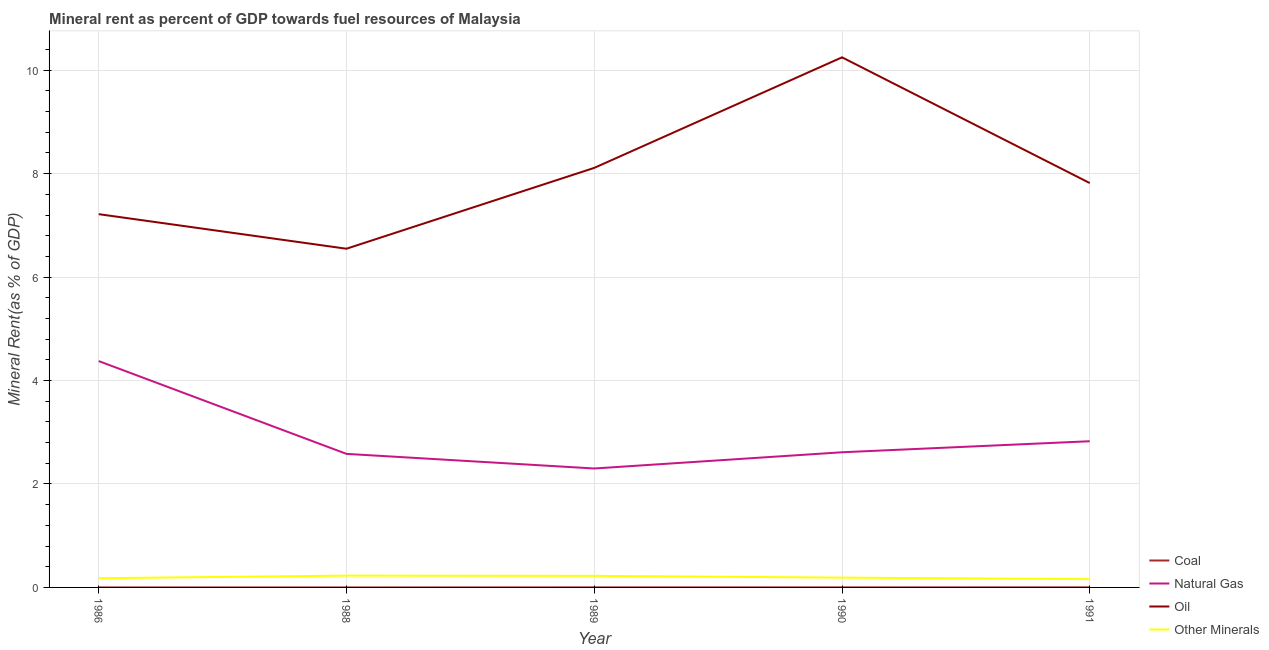How many different coloured lines are there?
Your answer should be very brief. 4. What is the coal rent in 1986?
Provide a short and direct response. 0. Across all years, what is the maximum oil rent?
Your answer should be compact. 10.25. Across all years, what is the minimum oil rent?
Provide a short and direct response. 6.55. In which year was the natural gas rent maximum?
Ensure brevity in your answer.  1986. What is the total  rent of other minerals in the graph?
Give a very brief answer. 0.98. What is the difference between the natural gas rent in 1990 and that in 1991?
Provide a short and direct response. -0.21. What is the difference between the oil rent in 1991 and the  rent of other minerals in 1990?
Ensure brevity in your answer.  7.63. What is the average coal rent per year?
Your response must be concise. 0. In the year 1991, what is the difference between the oil rent and coal rent?
Offer a terse response. 7.82. What is the ratio of the natural gas rent in 1989 to that in 1991?
Keep it short and to the point. 0.81. What is the difference between the highest and the second highest natural gas rent?
Offer a very short reply. 1.55. What is the difference between the highest and the lowest oil rent?
Keep it short and to the point. 3.7. Is it the case that in every year, the sum of the  rent of other minerals and coal rent is greater than the sum of natural gas rent and oil rent?
Your response must be concise. No. Does the natural gas rent monotonically increase over the years?
Keep it short and to the point. No. Is the  rent of other minerals strictly greater than the natural gas rent over the years?
Keep it short and to the point. No. How many years are there in the graph?
Make the answer very short. 5. Are the values on the major ticks of Y-axis written in scientific E-notation?
Make the answer very short. No. Does the graph contain any zero values?
Offer a terse response. No. Does the graph contain grids?
Your response must be concise. Yes. How are the legend labels stacked?
Your response must be concise. Vertical. What is the title of the graph?
Your answer should be very brief. Mineral rent as percent of GDP towards fuel resources of Malaysia. What is the label or title of the X-axis?
Your answer should be very brief. Year. What is the label or title of the Y-axis?
Offer a very short reply. Mineral Rent(as % of GDP). What is the Mineral Rent(as % of GDP) in Coal in 1986?
Keep it short and to the point. 0. What is the Mineral Rent(as % of GDP) of Natural Gas in 1986?
Your answer should be very brief. 4.38. What is the Mineral Rent(as % of GDP) in Oil in 1986?
Make the answer very short. 7.22. What is the Mineral Rent(as % of GDP) in Other Minerals in 1986?
Give a very brief answer. 0.18. What is the Mineral Rent(as % of GDP) of Coal in 1988?
Provide a succinct answer. 2.78843758347685e-6. What is the Mineral Rent(as % of GDP) in Natural Gas in 1988?
Make the answer very short. 2.58. What is the Mineral Rent(as % of GDP) in Oil in 1988?
Give a very brief answer. 6.55. What is the Mineral Rent(as % of GDP) of Other Minerals in 1988?
Your answer should be compact. 0.23. What is the Mineral Rent(as % of GDP) of Coal in 1989?
Your answer should be compact. 0. What is the Mineral Rent(as % of GDP) of Natural Gas in 1989?
Offer a terse response. 2.3. What is the Mineral Rent(as % of GDP) of Oil in 1989?
Offer a very short reply. 8.11. What is the Mineral Rent(as % of GDP) of Other Minerals in 1989?
Provide a succinct answer. 0.22. What is the Mineral Rent(as % of GDP) of Coal in 1990?
Ensure brevity in your answer.  0. What is the Mineral Rent(as % of GDP) in Natural Gas in 1990?
Ensure brevity in your answer.  2.61. What is the Mineral Rent(as % of GDP) of Oil in 1990?
Give a very brief answer. 10.25. What is the Mineral Rent(as % of GDP) of Other Minerals in 1990?
Your answer should be compact. 0.19. What is the Mineral Rent(as % of GDP) in Coal in 1991?
Give a very brief answer. 0. What is the Mineral Rent(as % of GDP) of Natural Gas in 1991?
Make the answer very short. 2.83. What is the Mineral Rent(as % of GDP) in Oil in 1991?
Provide a succinct answer. 7.82. What is the Mineral Rent(as % of GDP) of Other Minerals in 1991?
Your response must be concise. 0.16. Across all years, what is the maximum Mineral Rent(as % of GDP) of Coal?
Make the answer very short. 0. Across all years, what is the maximum Mineral Rent(as % of GDP) in Natural Gas?
Make the answer very short. 4.38. Across all years, what is the maximum Mineral Rent(as % of GDP) of Oil?
Your answer should be compact. 10.25. Across all years, what is the maximum Mineral Rent(as % of GDP) of Other Minerals?
Your answer should be very brief. 0.23. Across all years, what is the minimum Mineral Rent(as % of GDP) in Coal?
Offer a terse response. 2.78843758347685e-6. Across all years, what is the minimum Mineral Rent(as % of GDP) of Natural Gas?
Offer a very short reply. 2.3. Across all years, what is the minimum Mineral Rent(as % of GDP) in Oil?
Offer a terse response. 6.55. Across all years, what is the minimum Mineral Rent(as % of GDP) of Other Minerals?
Your answer should be compact. 0.16. What is the total Mineral Rent(as % of GDP) in Coal in the graph?
Provide a succinct answer. 0. What is the total Mineral Rent(as % of GDP) in Natural Gas in the graph?
Ensure brevity in your answer.  14.7. What is the total Mineral Rent(as % of GDP) in Oil in the graph?
Your answer should be compact. 39.94. What is the total Mineral Rent(as % of GDP) in Other Minerals in the graph?
Your response must be concise. 0.98. What is the difference between the Mineral Rent(as % of GDP) in Natural Gas in 1986 and that in 1988?
Give a very brief answer. 1.79. What is the difference between the Mineral Rent(as % of GDP) in Oil in 1986 and that in 1988?
Provide a succinct answer. 0.67. What is the difference between the Mineral Rent(as % of GDP) of Other Minerals in 1986 and that in 1988?
Your answer should be very brief. -0.05. What is the difference between the Mineral Rent(as % of GDP) in Coal in 1986 and that in 1989?
Your answer should be very brief. -0. What is the difference between the Mineral Rent(as % of GDP) of Natural Gas in 1986 and that in 1989?
Your answer should be very brief. 2.08. What is the difference between the Mineral Rent(as % of GDP) of Oil in 1986 and that in 1989?
Make the answer very short. -0.89. What is the difference between the Mineral Rent(as % of GDP) in Other Minerals in 1986 and that in 1989?
Provide a short and direct response. -0.05. What is the difference between the Mineral Rent(as % of GDP) of Coal in 1986 and that in 1990?
Offer a terse response. -0. What is the difference between the Mineral Rent(as % of GDP) in Natural Gas in 1986 and that in 1990?
Offer a terse response. 1.76. What is the difference between the Mineral Rent(as % of GDP) in Oil in 1986 and that in 1990?
Offer a very short reply. -3.03. What is the difference between the Mineral Rent(as % of GDP) of Other Minerals in 1986 and that in 1990?
Provide a succinct answer. -0.01. What is the difference between the Mineral Rent(as % of GDP) in Coal in 1986 and that in 1991?
Keep it short and to the point. -0. What is the difference between the Mineral Rent(as % of GDP) of Natural Gas in 1986 and that in 1991?
Ensure brevity in your answer.  1.55. What is the difference between the Mineral Rent(as % of GDP) of Oil in 1986 and that in 1991?
Ensure brevity in your answer.  -0.6. What is the difference between the Mineral Rent(as % of GDP) of Other Minerals in 1986 and that in 1991?
Provide a succinct answer. 0.02. What is the difference between the Mineral Rent(as % of GDP) in Coal in 1988 and that in 1989?
Give a very brief answer. -0. What is the difference between the Mineral Rent(as % of GDP) of Natural Gas in 1988 and that in 1989?
Offer a terse response. 0.28. What is the difference between the Mineral Rent(as % of GDP) in Oil in 1988 and that in 1989?
Ensure brevity in your answer.  -1.56. What is the difference between the Mineral Rent(as % of GDP) in Other Minerals in 1988 and that in 1989?
Your response must be concise. 0. What is the difference between the Mineral Rent(as % of GDP) in Coal in 1988 and that in 1990?
Your answer should be very brief. -0. What is the difference between the Mineral Rent(as % of GDP) of Natural Gas in 1988 and that in 1990?
Offer a terse response. -0.03. What is the difference between the Mineral Rent(as % of GDP) in Oil in 1988 and that in 1990?
Keep it short and to the point. -3.7. What is the difference between the Mineral Rent(as % of GDP) of Other Minerals in 1988 and that in 1990?
Provide a succinct answer. 0.04. What is the difference between the Mineral Rent(as % of GDP) of Coal in 1988 and that in 1991?
Your answer should be very brief. -0. What is the difference between the Mineral Rent(as % of GDP) of Natural Gas in 1988 and that in 1991?
Keep it short and to the point. -0.24. What is the difference between the Mineral Rent(as % of GDP) in Oil in 1988 and that in 1991?
Provide a succinct answer. -1.27. What is the difference between the Mineral Rent(as % of GDP) in Other Minerals in 1988 and that in 1991?
Provide a short and direct response. 0.07. What is the difference between the Mineral Rent(as % of GDP) in Coal in 1989 and that in 1990?
Offer a very short reply. -0. What is the difference between the Mineral Rent(as % of GDP) of Natural Gas in 1989 and that in 1990?
Offer a very short reply. -0.31. What is the difference between the Mineral Rent(as % of GDP) of Oil in 1989 and that in 1990?
Your response must be concise. -2.14. What is the difference between the Mineral Rent(as % of GDP) of Other Minerals in 1989 and that in 1990?
Give a very brief answer. 0.03. What is the difference between the Mineral Rent(as % of GDP) in Coal in 1989 and that in 1991?
Provide a succinct answer. -0. What is the difference between the Mineral Rent(as % of GDP) of Natural Gas in 1989 and that in 1991?
Your answer should be very brief. -0.53. What is the difference between the Mineral Rent(as % of GDP) of Oil in 1989 and that in 1991?
Make the answer very short. 0.29. What is the difference between the Mineral Rent(as % of GDP) in Other Minerals in 1989 and that in 1991?
Your answer should be very brief. 0.06. What is the difference between the Mineral Rent(as % of GDP) of Coal in 1990 and that in 1991?
Your response must be concise. -0. What is the difference between the Mineral Rent(as % of GDP) in Natural Gas in 1990 and that in 1991?
Provide a succinct answer. -0.21. What is the difference between the Mineral Rent(as % of GDP) of Oil in 1990 and that in 1991?
Make the answer very short. 2.43. What is the difference between the Mineral Rent(as % of GDP) in Other Minerals in 1990 and that in 1991?
Keep it short and to the point. 0.03. What is the difference between the Mineral Rent(as % of GDP) in Coal in 1986 and the Mineral Rent(as % of GDP) in Natural Gas in 1988?
Ensure brevity in your answer.  -2.58. What is the difference between the Mineral Rent(as % of GDP) of Coal in 1986 and the Mineral Rent(as % of GDP) of Oil in 1988?
Offer a very short reply. -6.55. What is the difference between the Mineral Rent(as % of GDP) in Coal in 1986 and the Mineral Rent(as % of GDP) in Other Minerals in 1988?
Offer a very short reply. -0.23. What is the difference between the Mineral Rent(as % of GDP) of Natural Gas in 1986 and the Mineral Rent(as % of GDP) of Oil in 1988?
Give a very brief answer. -2.17. What is the difference between the Mineral Rent(as % of GDP) in Natural Gas in 1986 and the Mineral Rent(as % of GDP) in Other Minerals in 1988?
Keep it short and to the point. 4.15. What is the difference between the Mineral Rent(as % of GDP) of Oil in 1986 and the Mineral Rent(as % of GDP) of Other Minerals in 1988?
Your answer should be compact. 6.99. What is the difference between the Mineral Rent(as % of GDP) of Coal in 1986 and the Mineral Rent(as % of GDP) of Natural Gas in 1989?
Offer a very short reply. -2.3. What is the difference between the Mineral Rent(as % of GDP) in Coal in 1986 and the Mineral Rent(as % of GDP) in Oil in 1989?
Offer a terse response. -8.11. What is the difference between the Mineral Rent(as % of GDP) of Coal in 1986 and the Mineral Rent(as % of GDP) of Other Minerals in 1989?
Provide a short and direct response. -0.22. What is the difference between the Mineral Rent(as % of GDP) in Natural Gas in 1986 and the Mineral Rent(as % of GDP) in Oil in 1989?
Offer a very short reply. -3.73. What is the difference between the Mineral Rent(as % of GDP) in Natural Gas in 1986 and the Mineral Rent(as % of GDP) in Other Minerals in 1989?
Your response must be concise. 4.15. What is the difference between the Mineral Rent(as % of GDP) in Oil in 1986 and the Mineral Rent(as % of GDP) in Other Minerals in 1989?
Your response must be concise. 6.99. What is the difference between the Mineral Rent(as % of GDP) in Coal in 1986 and the Mineral Rent(as % of GDP) in Natural Gas in 1990?
Offer a terse response. -2.61. What is the difference between the Mineral Rent(as % of GDP) in Coal in 1986 and the Mineral Rent(as % of GDP) in Oil in 1990?
Offer a terse response. -10.25. What is the difference between the Mineral Rent(as % of GDP) of Coal in 1986 and the Mineral Rent(as % of GDP) of Other Minerals in 1990?
Your answer should be compact. -0.19. What is the difference between the Mineral Rent(as % of GDP) of Natural Gas in 1986 and the Mineral Rent(as % of GDP) of Oil in 1990?
Keep it short and to the point. -5.87. What is the difference between the Mineral Rent(as % of GDP) of Natural Gas in 1986 and the Mineral Rent(as % of GDP) of Other Minerals in 1990?
Keep it short and to the point. 4.19. What is the difference between the Mineral Rent(as % of GDP) of Oil in 1986 and the Mineral Rent(as % of GDP) of Other Minerals in 1990?
Provide a short and direct response. 7.03. What is the difference between the Mineral Rent(as % of GDP) in Coal in 1986 and the Mineral Rent(as % of GDP) in Natural Gas in 1991?
Ensure brevity in your answer.  -2.83. What is the difference between the Mineral Rent(as % of GDP) of Coal in 1986 and the Mineral Rent(as % of GDP) of Oil in 1991?
Your response must be concise. -7.82. What is the difference between the Mineral Rent(as % of GDP) in Coal in 1986 and the Mineral Rent(as % of GDP) in Other Minerals in 1991?
Offer a terse response. -0.16. What is the difference between the Mineral Rent(as % of GDP) in Natural Gas in 1986 and the Mineral Rent(as % of GDP) in Oil in 1991?
Provide a short and direct response. -3.44. What is the difference between the Mineral Rent(as % of GDP) in Natural Gas in 1986 and the Mineral Rent(as % of GDP) in Other Minerals in 1991?
Make the answer very short. 4.22. What is the difference between the Mineral Rent(as % of GDP) in Oil in 1986 and the Mineral Rent(as % of GDP) in Other Minerals in 1991?
Provide a short and direct response. 7.06. What is the difference between the Mineral Rent(as % of GDP) of Coal in 1988 and the Mineral Rent(as % of GDP) of Natural Gas in 1989?
Provide a short and direct response. -2.3. What is the difference between the Mineral Rent(as % of GDP) of Coal in 1988 and the Mineral Rent(as % of GDP) of Oil in 1989?
Ensure brevity in your answer.  -8.11. What is the difference between the Mineral Rent(as % of GDP) in Coal in 1988 and the Mineral Rent(as % of GDP) in Other Minerals in 1989?
Your answer should be very brief. -0.22. What is the difference between the Mineral Rent(as % of GDP) in Natural Gas in 1988 and the Mineral Rent(as % of GDP) in Oil in 1989?
Offer a very short reply. -5.53. What is the difference between the Mineral Rent(as % of GDP) of Natural Gas in 1988 and the Mineral Rent(as % of GDP) of Other Minerals in 1989?
Your answer should be very brief. 2.36. What is the difference between the Mineral Rent(as % of GDP) in Oil in 1988 and the Mineral Rent(as % of GDP) in Other Minerals in 1989?
Your answer should be compact. 6.32. What is the difference between the Mineral Rent(as % of GDP) of Coal in 1988 and the Mineral Rent(as % of GDP) of Natural Gas in 1990?
Make the answer very short. -2.61. What is the difference between the Mineral Rent(as % of GDP) of Coal in 1988 and the Mineral Rent(as % of GDP) of Oil in 1990?
Offer a very short reply. -10.25. What is the difference between the Mineral Rent(as % of GDP) of Coal in 1988 and the Mineral Rent(as % of GDP) of Other Minerals in 1990?
Ensure brevity in your answer.  -0.19. What is the difference between the Mineral Rent(as % of GDP) in Natural Gas in 1988 and the Mineral Rent(as % of GDP) in Oil in 1990?
Provide a short and direct response. -7.67. What is the difference between the Mineral Rent(as % of GDP) in Natural Gas in 1988 and the Mineral Rent(as % of GDP) in Other Minerals in 1990?
Your answer should be compact. 2.39. What is the difference between the Mineral Rent(as % of GDP) in Oil in 1988 and the Mineral Rent(as % of GDP) in Other Minerals in 1990?
Make the answer very short. 6.36. What is the difference between the Mineral Rent(as % of GDP) of Coal in 1988 and the Mineral Rent(as % of GDP) of Natural Gas in 1991?
Offer a terse response. -2.83. What is the difference between the Mineral Rent(as % of GDP) of Coal in 1988 and the Mineral Rent(as % of GDP) of Oil in 1991?
Offer a very short reply. -7.82. What is the difference between the Mineral Rent(as % of GDP) of Coal in 1988 and the Mineral Rent(as % of GDP) of Other Minerals in 1991?
Your answer should be compact. -0.16. What is the difference between the Mineral Rent(as % of GDP) of Natural Gas in 1988 and the Mineral Rent(as % of GDP) of Oil in 1991?
Offer a terse response. -5.24. What is the difference between the Mineral Rent(as % of GDP) of Natural Gas in 1988 and the Mineral Rent(as % of GDP) of Other Minerals in 1991?
Your response must be concise. 2.42. What is the difference between the Mineral Rent(as % of GDP) of Oil in 1988 and the Mineral Rent(as % of GDP) of Other Minerals in 1991?
Make the answer very short. 6.39. What is the difference between the Mineral Rent(as % of GDP) in Coal in 1989 and the Mineral Rent(as % of GDP) in Natural Gas in 1990?
Your response must be concise. -2.61. What is the difference between the Mineral Rent(as % of GDP) in Coal in 1989 and the Mineral Rent(as % of GDP) in Oil in 1990?
Provide a succinct answer. -10.25. What is the difference between the Mineral Rent(as % of GDP) of Coal in 1989 and the Mineral Rent(as % of GDP) of Other Minerals in 1990?
Provide a short and direct response. -0.19. What is the difference between the Mineral Rent(as % of GDP) in Natural Gas in 1989 and the Mineral Rent(as % of GDP) in Oil in 1990?
Offer a terse response. -7.95. What is the difference between the Mineral Rent(as % of GDP) of Natural Gas in 1989 and the Mineral Rent(as % of GDP) of Other Minerals in 1990?
Provide a short and direct response. 2.11. What is the difference between the Mineral Rent(as % of GDP) in Oil in 1989 and the Mineral Rent(as % of GDP) in Other Minerals in 1990?
Your answer should be compact. 7.92. What is the difference between the Mineral Rent(as % of GDP) in Coal in 1989 and the Mineral Rent(as % of GDP) in Natural Gas in 1991?
Offer a very short reply. -2.83. What is the difference between the Mineral Rent(as % of GDP) in Coal in 1989 and the Mineral Rent(as % of GDP) in Oil in 1991?
Your response must be concise. -7.82. What is the difference between the Mineral Rent(as % of GDP) in Coal in 1989 and the Mineral Rent(as % of GDP) in Other Minerals in 1991?
Give a very brief answer. -0.16. What is the difference between the Mineral Rent(as % of GDP) of Natural Gas in 1989 and the Mineral Rent(as % of GDP) of Oil in 1991?
Offer a very short reply. -5.52. What is the difference between the Mineral Rent(as % of GDP) in Natural Gas in 1989 and the Mineral Rent(as % of GDP) in Other Minerals in 1991?
Give a very brief answer. 2.14. What is the difference between the Mineral Rent(as % of GDP) in Oil in 1989 and the Mineral Rent(as % of GDP) in Other Minerals in 1991?
Keep it short and to the point. 7.95. What is the difference between the Mineral Rent(as % of GDP) in Coal in 1990 and the Mineral Rent(as % of GDP) in Natural Gas in 1991?
Offer a terse response. -2.83. What is the difference between the Mineral Rent(as % of GDP) in Coal in 1990 and the Mineral Rent(as % of GDP) in Oil in 1991?
Your answer should be very brief. -7.82. What is the difference between the Mineral Rent(as % of GDP) in Coal in 1990 and the Mineral Rent(as % of GDP) in Other Minerals in 1991?
Keep it short and to the point. -0.16. What is the difference between the Mineral Rent(as % of GDP) in Natural Gas in 1990 and the Mineral Rent(as % of GDP) in Oil in 1991?
Ensure brevity in your answer.  -5.2. What is the difference between the Mineral Rent(as % of GDP) in Natural Gas in 1990 and the Mineral Rent(as % of GDP) in Other Minerals in 1991?
Provide a succinct answer. 2.45. What is the difference between the Mineral Rent(as % of GDP) in Oil in 1990 and the Mineral Rent(as % of GDP) in Other Minerals in 1991?
Your answer should be compact. 10.09. What is the average Mineral Rent(as % of GDP) of Coal per year?
Ensure brevity in your answer.  0. What is the average Mineral Rent(as % of GDP) in Natural Gas per year?
Provide a short and direct response. 2.94. What is the average Mineral Rent(as % of GDP) of Oil per year?
Provide a short and direct response. 7.99. What is the average Mineral Rent(as % of GDP) in Other Minerals per year?
Make the answer very short. 0.2. In the year 1986, what is the difference between the Mineral Rent(as % of GDP) of Coal and Mineral Rent(as % of GDP) of Natural Gas?
Give a very brief answer. -4.38. In the year 1986, what is the difference between the Mineral Rent(as % of GDP) of Coal and Mineral Rent(as % of GDP) of Oil?
Offer a very short reply. -7.22. In the year 1986, what is the difference between the Mineral Rent(as % of GDP) in Coal and Mineral Rent(as % of GDP) in Other Minerals?
Offer a very short reply. -0.18. In the year 1986, what is the difference between the Mineral Rent(as % of GDP) in Natural Gas and Mineral Rent(as % of GDP) in Oil?
Give a very brief answer. -2.84. In the year 1986, what is the difference between the Mineral Rent(as % of GDP) in Natural Gas and Mineral Rent(as % of GDP) in Other Minerals?
Offer a terse response. 4.2. In the year 1986, what is the difference between the Mineral Rent(as % of GDP) of Oil and Mineral Rent(as % of GDP) of Other Minerals?
Offer a very short reply. 7.04. In the year 1988, what is the difference between the Mineral Rent(as % of GDP) in Coal and Mineral Rent(as % of GDP) in Natural Gas?
Provide a succinct answer. -2.58. In the year 1988, what is the difference between the Mineral Rent(as % of GDP) in Coal and Mineral Rent(as % of GDP) in Oil?
Make the answer very short. -6.55. In the year 1988, what is the difference between the Mineral Rent(as % of GDP) in Coal and Mineral Rent(as % of GDP) in Other Minerals?
Provide a short and direct response. -0.23. In the year 1988, what is the difference between the Mineral Rent(as % of GDP) in Natural Gas and Mineral Rent(as % of GDP) in Oil?
Your answer should be very brief. -3.97. In the year 1988, what is the difference between the Mineral Rent(as % of GDP) of Natural Gas and Mineral Rent(as % of GDP) of Other Minerals?
Give a very brief answer. 2.35. In the year 1988, what is the difference between the Mineral Rent(as % of GDP) of Oil and Mineral Rent(as % of GDP) of Other Minerals?
Provide a succinct answer. 6.32. In the year 1989, what is the difference between the Mineral Rent(as % of GDP) of Coal and Mineral Rent(as % of GDP) of Natural Gas?
Provide a short and direct response. -2.3. In the year 1989, what is the difference between the Mineral Rent(as % of GDP) in Coal and Mineral Rent(as % of GDP) in Oil?
Your answer should be compact. -8.11. In the year 1989, what is the difference between the Mineral Rent(as % of GDP) in Coal and Mineral Rent(as % of GDP) in Other Minerals?
Provide a short and direct response. -0.22. In the year 1989, what is the difference between the Mineral Rent(as % of GDP) in Natural Gas and Mineral Rent(as % of GDP) in Oil?
Provide a short and direct response. -5.81. In the year 1989, what is the difference between the Mineral Rent(as % of GDP) in Natural Gas and Mineral Rent(as % of GDP) in Other Minerals?
Ensure brevity in your answer.  2.08. In the year 1989, what is the difference between the Mineral Rent(as % of GDP) of Oil and Mineral Rent(as % of GDP) of Other Minerals?
Keep it short and to the point. 7.89. In the year 1990, what is the difference between the Mineral Rent(as % of GDP) in Coal and Mineral Rent(as % of GDP) in Natural Gas?
Ensure brevity in your answer.  -2.61. In the year 1990, what is the difference between the Mineral Rent(as % of GDP) in Coal and Mineral Rent(as % of GDP) in Oil?
Ensure brevity in your answer.  -10.25. In the year 1990, what is the difference between the Mineral Rent(as % of GDP) of Coal and Mineral Rent(as % of GDP) of Other Minerals?
Make the answer very short. -0.19. In the year 1990, what is the difference between the Mineral Rent(as % of GDP) of Natural Gas and Mineral Rent(as % of GDP) of Oil?
Keep it short and to the point. -7.64. In the year 1990, what is the difference between the Mineral Rent(as % of GDP) in Natural Gas and Mineral Rent(as % of GDP) in Other Minerals?
Ensure brevity in your answer.  2.42. In the year 1990, what is the difference between the Mineral Rent(as % of GDP) of Oil and Mineral Rent(as % of GDP) of Other Minerals?
Your response must be concise. 10.06. In the year 1991, what is the difference between the Mineral Rent(as % of GDP) in Coal and Mineral Rent(as % of GDP) in Natural Gas?
Give a very brief answer. -2.83. In the year 1991, what is the difference between the Mineral Rent(as % of GDP) of Coal and Mineral Rent(as % of GDP) of Oil?
Ensure brevity in your answer.  -7.82. In the year 1991, what is the difference between the Mineral Rent(as % of GDP) in Coal and Mineral Rent(as % of GDP) in Other Minerals?
Offer a terse response. -0.16. In the year 1991, what is the difference between the Mineral Rent(as % of GDP) in Natural Gas and Mineral Rent(as % of GDP) in Oil?
Your response must be concise. -4.99. In the year 1991, what is the difference between the Mineral Rent(as % of GDP) in Natural Gas and Mineral Rent(as % of GDP) in Other Minerals?
Offer a terse response. 2.67. In the year 1991, what is the difference between the Mineral Rent(as % of GDP) of Oil and Mineral Rent(as % of GDP) of Other Minerals?
Provide a succinct answer. 7.66. What is the ratio of the Mineral Rent(as % of GDP) of Coal in 1986 to that in 1988?
Offer a terse response. 95.67. What is the ratio of the Mineral Rent(as % of GDP) in Natural Gas in 1986 to that in 1988?
Your response must be concise. 1.69. What is the ratio of the Mineral Rent(as % of GDP) of Oil in 1986 to that in 1988?
Offer a terse response. 1.1. What is the ratio of the Mineral Rent(as % of GDP) in Other Minerals in 1986 to that in 1988?
Give a very brief answer. 0.78. What is the ratio of the Mineral Rent(as % of GDP) in Coal in 1986 to that in 1989?
Provide a short and direct response. 0.31. What is the ratio of the Mineral Rent(as % of GDP) of Natural Gas in 1986 to that in 1989?
Your answer should be compact. 1.9. What is the ratio of the Mineral Rent(as % of GDP) of Oil in 1986 to that in 1989?
Offer a very short reply. 0.89. What is the ratio of the Mineral Rent(as % of GDP) of Other Minerals in 1986 to that in 1989?
Offer a very short reply. 0.79. What is the ratio of the Mineral Rent(as % of GDP) in Coal in 1986 to that in 1990?
Make the answer very short. 0.29. What is the ratio of the Mineral Rent(as % of GDP) in Natural Gas in 1986 to that in 1990?
Make the answer very short. 1.67. What is the ratio of the Mineral Rent(as % of GDP) in Oil in 1986 to that in 1990?
Your answer should be very brief. 0.7. What is the ratio of the Mineral Rent(as % of GDP) of Other Minerals in 1986 to that in 1990?
Give a very brief answer. 0.94. What is the ratio of the Mineral Rent(as % of GDP) of Coal in 1986 to that in 1991?
Provide a short and direct response. 0.22. What is the ratio of the Mineral Rent(as % of GDP) of Natural Gas in 1986 to that in 1991?
Give a very brief answer. 1.55. What is the ratio of the Mineral Rent(as % of GDP) in Oil in 1986 to that in 1991?
Offer a very short reply. 0.92. What is the ratio of the Mineral Rent(as % of GDP) of Other Minerals in 1986 to that in 1991?
Make the answer very short. 1.11. What is the ratio of the Mineral Rent(as % of GDP) of Coal in 1988 to that in 1989?
Offer a terse response. 0. What is the ratio of the Mineral Rent(as % of GDP) of Natural Gas in 1988 to that in 1989?
Keep it short and to the point. 1.12. What is the ratio of the Mineral Rent(as % of GDP) in Oil in 1988 to that in 1989?
Your answer should be very brief. 0.81. What is the ratio of the Mineral Rent(as % of GDP) in Other Minerals in 1988 to that in 1989?
Give a very brief answer. 1.02. What is the ratio of the Mineral Rent(as % of GDP) of Coal in 1988 to that in 1990?
Your answer should be very brief. 0. What is the ratio of the Mineral Rent(as % of GDP) in Oil in 1988 to that in 1990?
Provide a succinct answer. 0.64. What is the ratio of the Mineral Rent(as % of GDP) in Other Minerals in 1988 to that in 1990?
Offer a very short reply. 1.2. What is the ratio of the Mineral Rent(as % of GDP) of Coal in 1988 to that in 1991?
Give a very brief answer. 0. What is the ratio of the Mineral Rent(as % of GDP) in Natural Gas in 1988 to that in 1991?
Your response must be concise. 0.91. What is the ratio of the Mineral Rent(as % of GDP) of Oil in 1988 to that in 1991?
Make the answer very short. 0.84. What is the ratio of the Mineral Rent(as % of GDP) of Other Minerals in 1988 to that in 1991?
Give a very brief answer. 1.43. What is the ratio of the Mineral Rent(as % of GDP) of Coal in 1989 to that in 1990?
Ensure brevity in your answer.  0.94. What is the ratio of the Mineral Rent(as % of GDP) of Natural Gas in 1989 to that in 1990?
Ensure brevity in your answer.  0.88. What is the ratio of the Mineral Rent(as % of GDP) of Oil in 1989 to that in 1990?
Ensure brevity in your answer.  0.79. What is the ratio of the Mineral Rent(as % of GDP) in Other Minerals in 1989 to that in 1990?
Give a very brief answer. 1.18. What is the ratio of the Mineral Rent(as % of GDP) of Coal in 1989 to that in 1991?
Your answer should be very brief. 0.72. What is the ratio of the Mineral Rent(as % of GDP) in Natural Gas in 1989 to that in 1991?
Your answer should be compact. 0.81. What is the ratio of the Mineral Rent(as % of GDP) in Oil in 1989 to that in 1991?
Your answer should be very brief. 1.04. What is the ratio of the Mineral Rent(as % of GDP) in Other Minerals in 1989 to that in 1991?
Provide a short and direct response. 1.4. What is the ratio of the Mineral Rent(as % of GDP) in Coal in 1990 to that in 1991?
Your response must be concise. 0.77. What is the ratio of the Mineral Rent(as % of GDP) of Natural Gas in 1990 to that in 1991?
Provide a short and direct response. 0.92. What is the ratio of the Mineral Rent(as % of GDP) of Oil in 1990 to that in 1991?
Provide a short and direct response. 1.31. What is the ratio of the Mineral Rent(as % of GDP) in Other Minerals in 1990 to that in 1991?
Give a very brief answer. 1.18. What is the difference between the highest and the second highest Mineral Rent(as % of GDP) of Natural Gas?
Your response must be concise. 1.55. What is the difference between the highest and the second highest Mineral Rent(as % of GDP) of Oil?
Your response must be concise. 2.14. What is the difference between the highest and the second highest Mineral Rent(as % of GDP) in Other Minerals?
Make the answer very short. 0. What is the difference between the highest and the lowest Mineral Rent(as % of GDP) of Coal?
Give a very brief answer. 0. What is the difference between the highest and the lowest Mineral Rent(as % of GDP) of Natural Gas?
Provide a short and direct response. 2.08. What is the difference between the highest and the lowest Mineral Rent(as % of GDP) of Oil?
Give a very brief answer. 3.7. What is the difference between the highest and the lowest Mineral Rent(as % of GDP) in Other Minerals?
Offer a terse response. 0.07. 